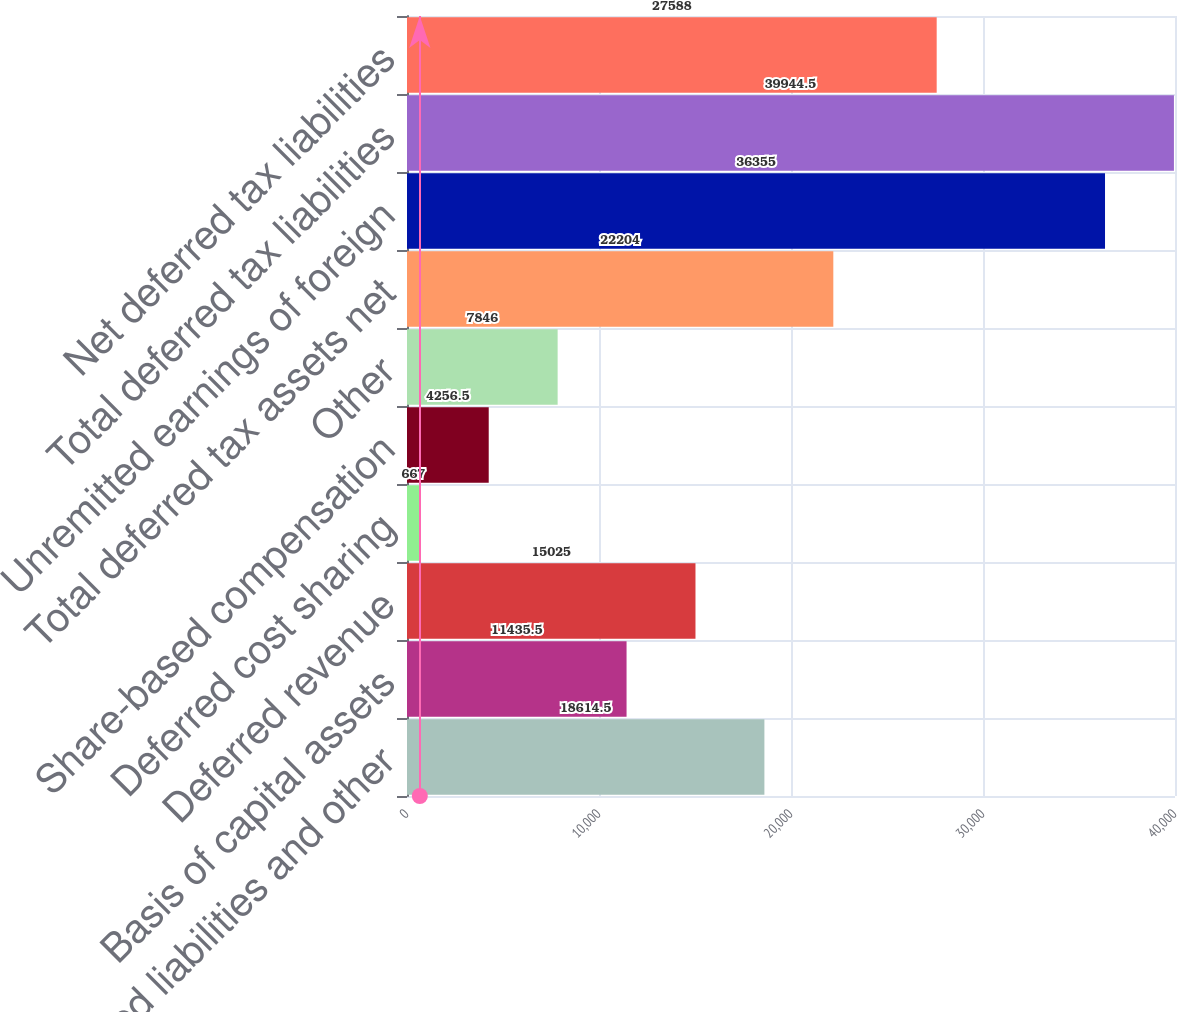Convert chart. <chart><loc_0><loc_0><loc_500><loc_500><bar_chart><fcel>Accrued liabilities and other<fcel>Basis of capital assets<fcel>Deferred revenue<fcel>Deferred cost sharing<fcel>Share-based compensation<fcel>Other<fcel>Total deferred tax assets net<fcel>Unremitted earnings of foreign<fcel>Total deferred tax liabilities<fcel>Net deferred tax liabilities<nl><fcel>18614.5<fcel>11435.5<fcel>15025<fcel>667<fcel>4256.5<fcel>7846<fcel>22204<fcel>36355<fcel>39944.5<fcel>27588<nl></chart> 